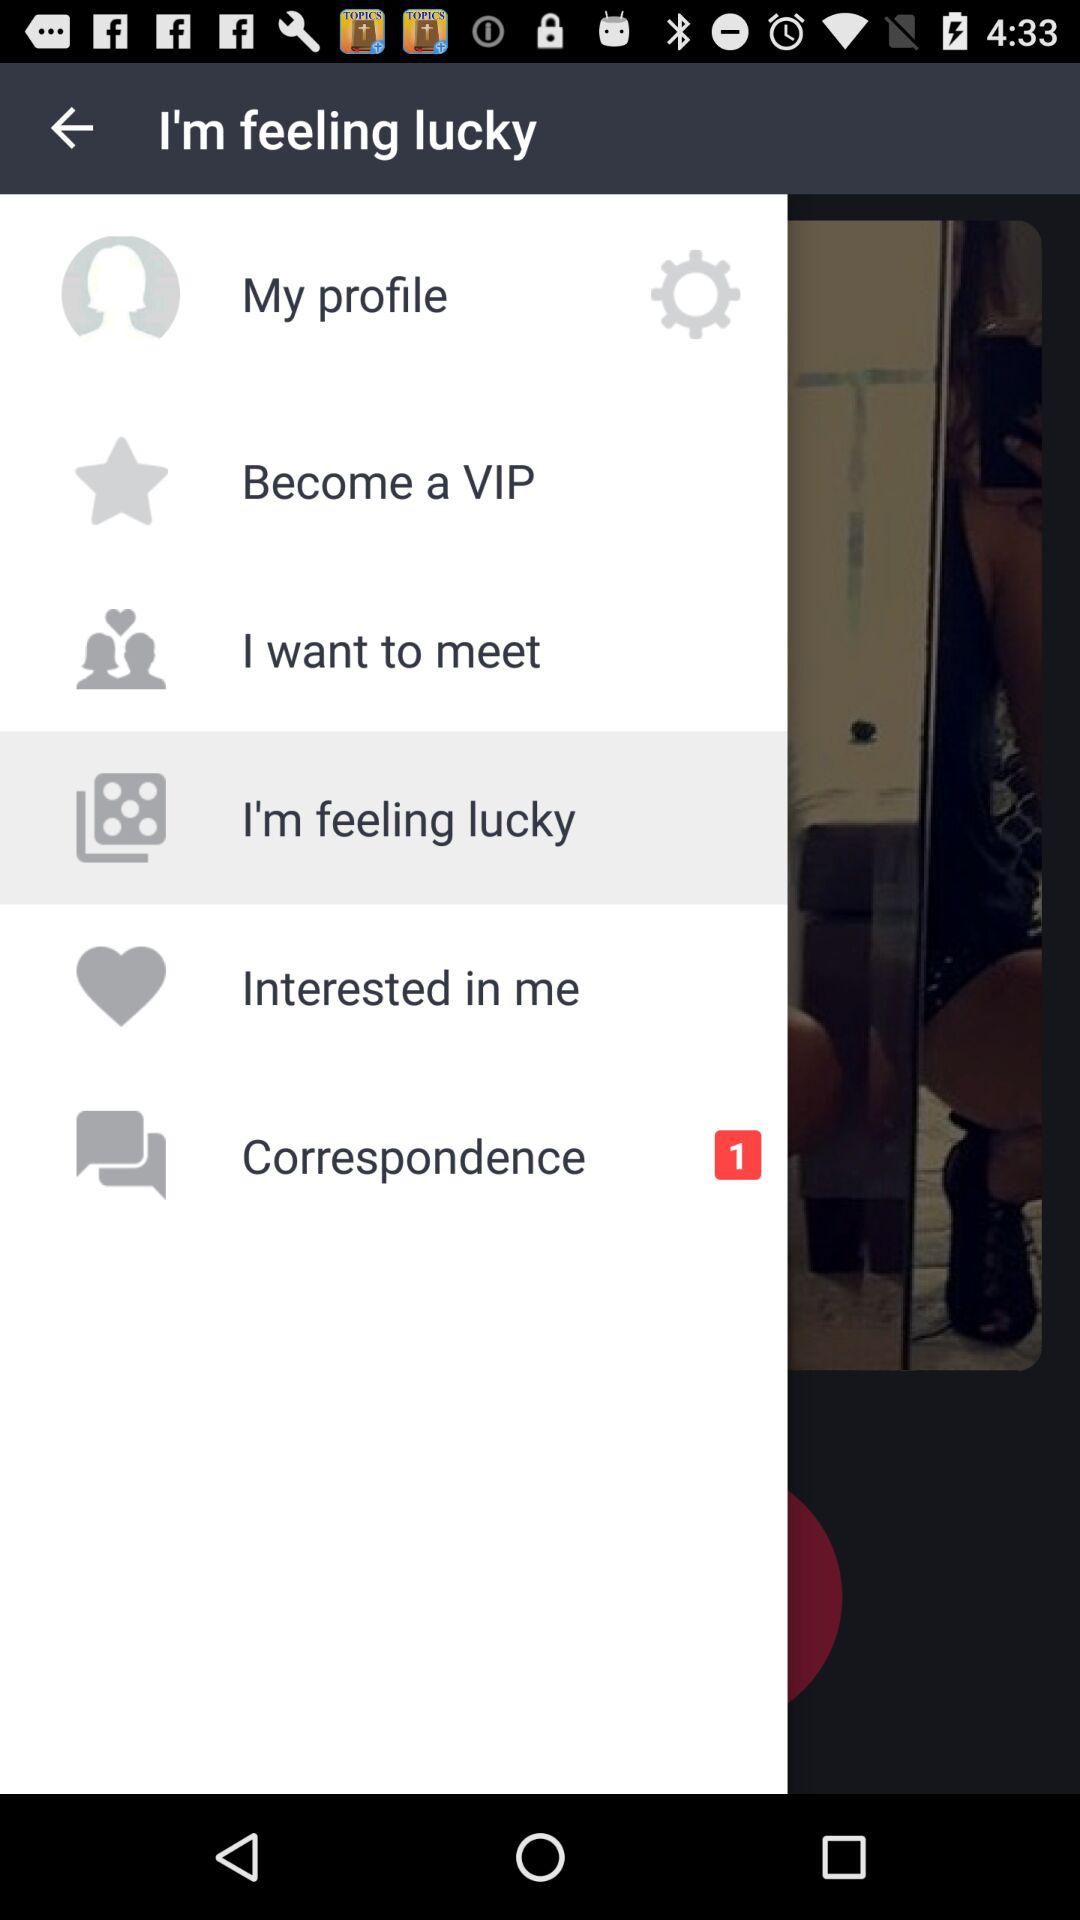How many unread correspondences are shown there? There is 1 unread correspondence. 